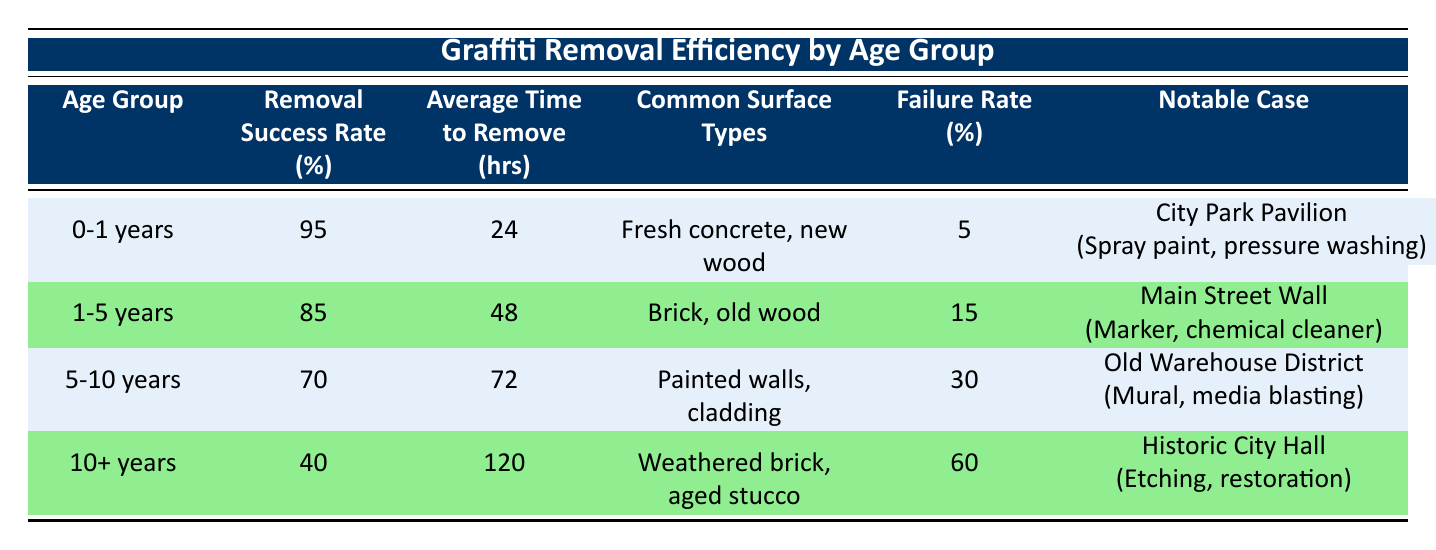What is the removal success rate for the age group 0-1 years? The table specifies that the removal success rate for the age group 0-1 years is listed directly in the corresponding row. This value is 95%.
Answer: 95% What is the average time to remove graffiti from surfaces aged 10+ years? The table indicates that the average time to remove graffiti from surfaces aged 10+ years is 120 hours, as stated in that row.
Answer: 120 hours Which age group has the lowest removal success rate? By comparing the removal success rates across all age groups, the age group 10+ years has the lowest rate at 40%, making it the least effective in graffiti removal.
Answer: 10+ years How many years does graffiti removal for the 5-10 years age group typically take on average? According to the data in the table, the average time to remove graffiti in the age group 5-10 years is 72 hours, mentioned directly in that row.
Answer: 72 hours Is the failure rate for the age group 1-5 years greater than for the age group 0-1 years? The failure rate for the age group 1-5 years is 15%, while for the 0-1 years group, it is 5%. Since 15% is greater than 5%, the statement is true.
Answer: Yes What percentage difference exists in removal success rates between the 0-1 years and 10+ years age groups? To find the percentage difference, we calculate it as follows: 95% (0-1 years) - 40% (10+ years) = 55%. Therefore, the percentage difference in removal success rates is 55%.
Answer: 55% Which surface types are common for graffiti removal in the age group 5-10 years? The table indicates that the common surface types for the age group 5-10 years include painted walls and cladding, stated directly in its row.
Answer: Painted walls, cladding Does the notable case in the 1-5 years category have a successful outcome? The notable case for the 1-5 years age group states that the graffiti removal was partially successful. Therefore, the answer is no, it did not achieve full success.
Answer: No What are the common surface types for the age group with the highest failure rate? The age group with the highest failure rate is 10+ years, which has common surface types listed as weathered brick and aged stucco in the table.
Answer: Weathered brick, aged stucco 